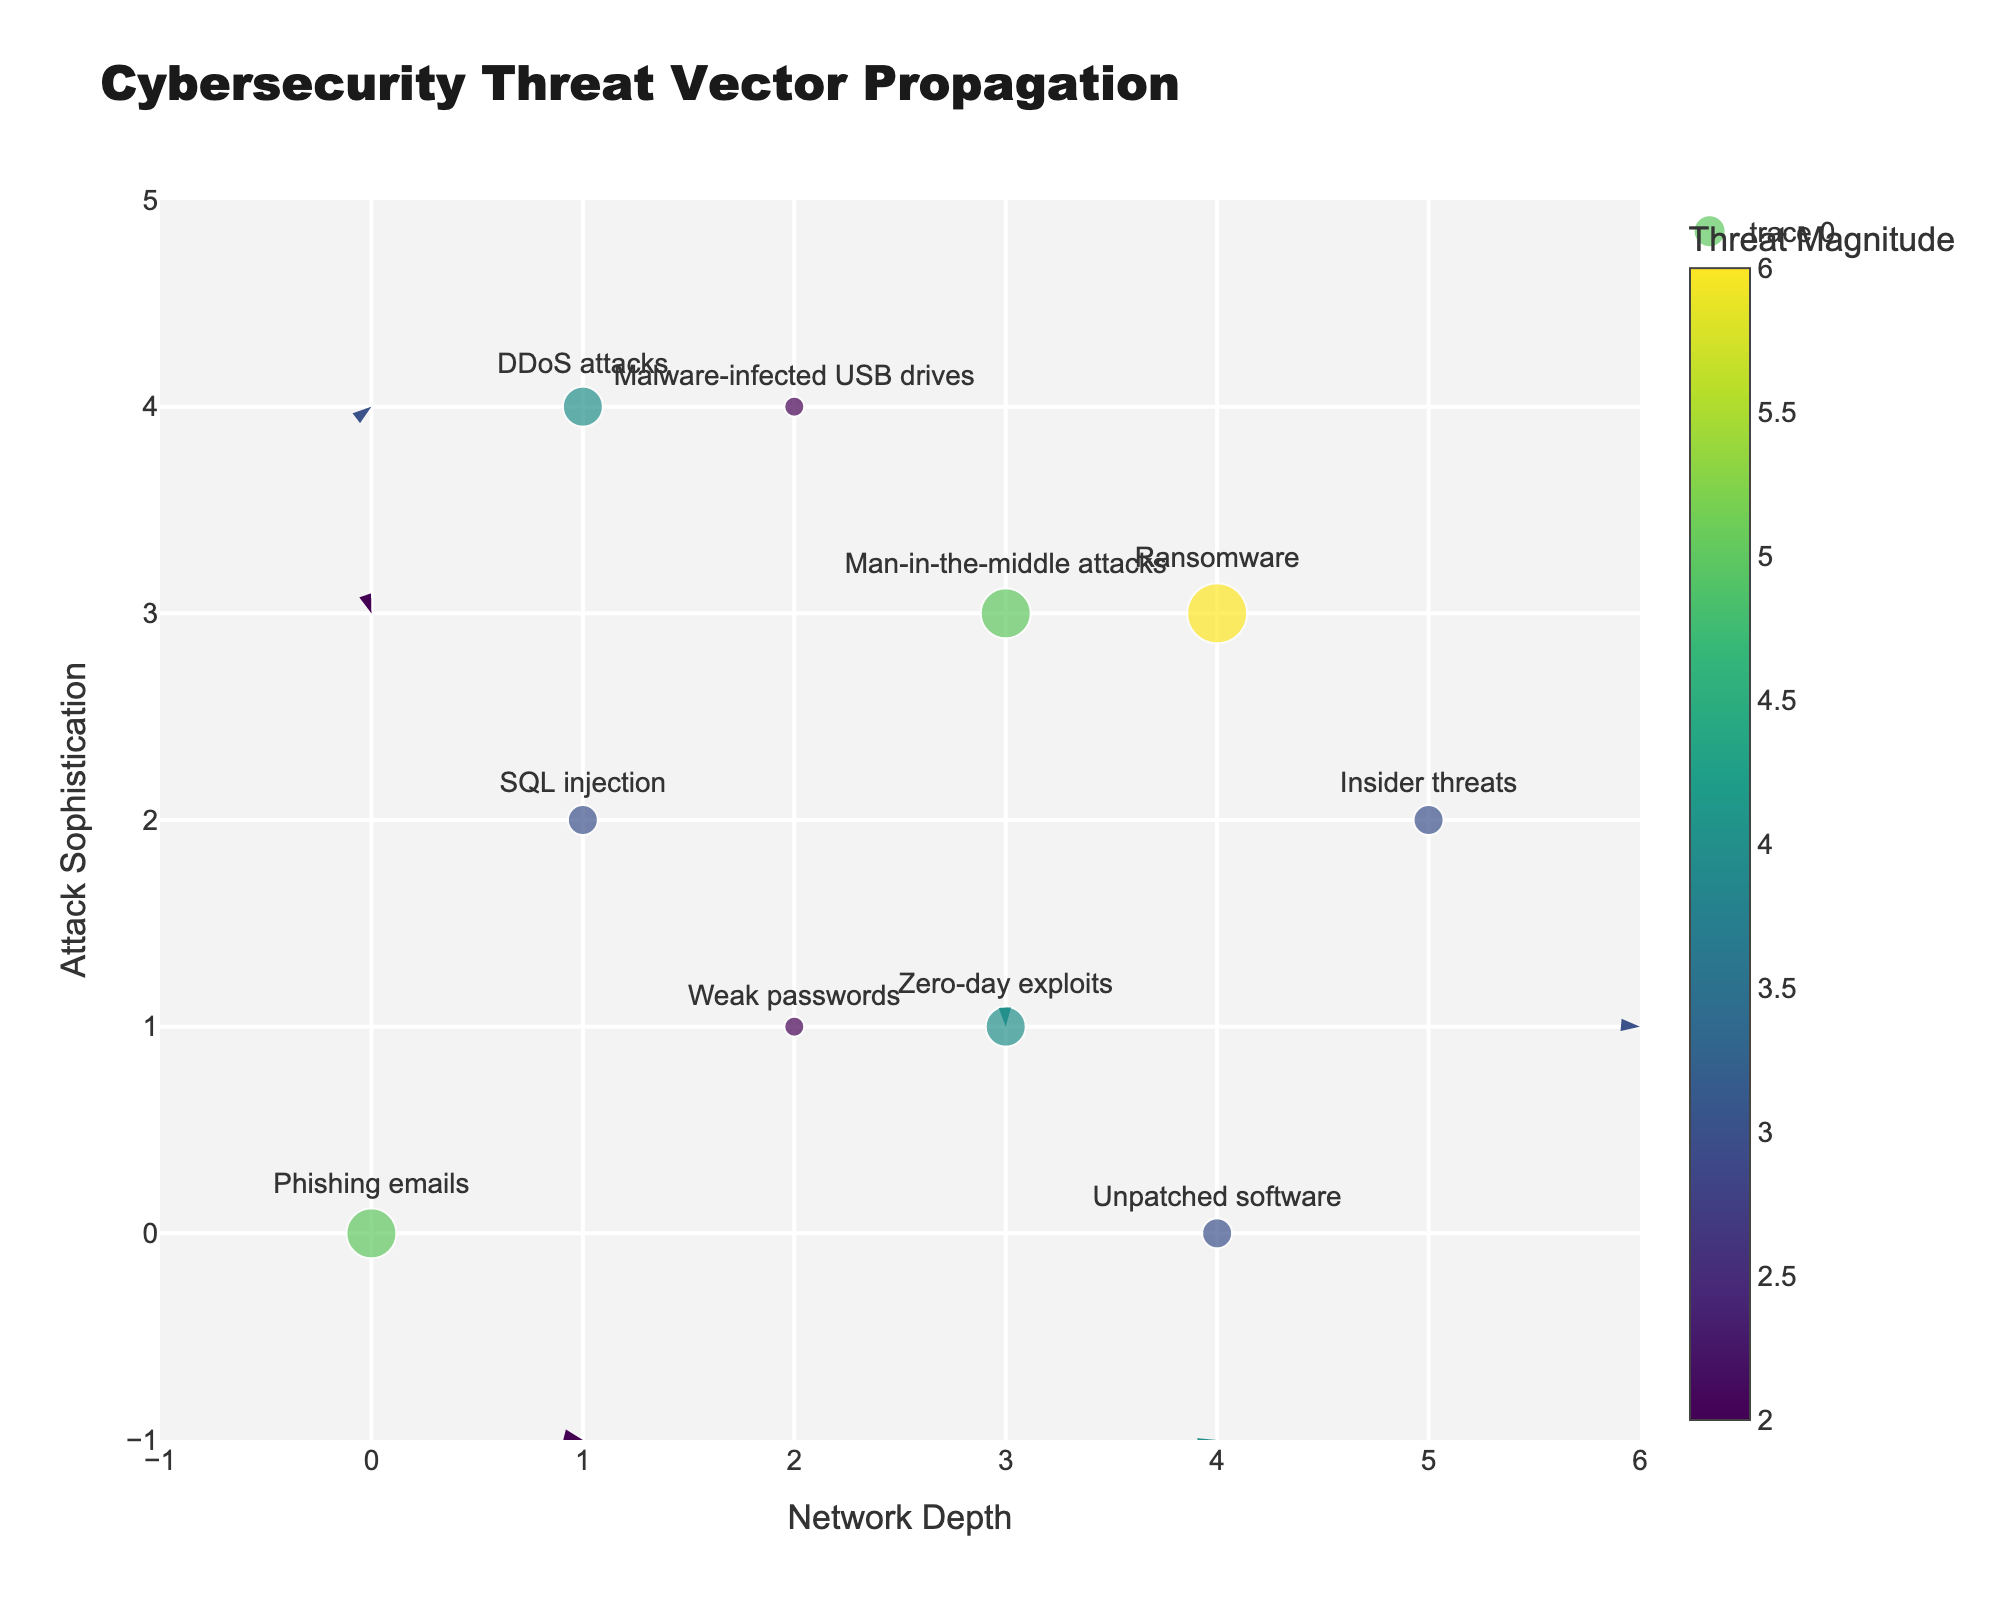what is the title of the plot? The title is usually the largest text at the top center of the figure. In this case, it reads "Cybersecurity Threat Vector Propagation" as specified in the code.
Answer: Cybersecurity Threat Vector Propagation what does the colorbar indicate? The colorbar is color-graded and titled "Threat Magnitude," which means it indicates the magnitude of each cybersecurity threat vector.
Answer: Threat Magnitude how many total threat vectors are represented in the plot? By counting the number of unique threat vectors indicated by the texts near the markers, we find there are 10 as listed in the data.
Answer: 10 which threat vector has the highest magnitude? Looking at the figure, the marker with the highest threat magnitude based on size and color is "Ransomware" with a magnitude of 6.
Answer: Ransomware what is the color of the marker indicating "Weak passwords"? By identifying the color corresponding to the magnitude value of 2 in the color scale (Viridis) on the colorbar, it shows a dark color.
Answer: Dark color where is the marker representing "DDoS attacks" located? The position of "DDoS attacks" can be found by locating the text for "DDoS attacks" next to its marker. It is at coordinates (1, 4).
Answer: (1, 4) how does the vector direction for "Insider threats" compare to "Zero-day exploits"? Comparing the directions, "Insider threats" points roughly upwards and to the right (positive direction), whereas "Zero-day exploits" points downwards and to the left (negative direction).
Answer: Opposite directions are there any threat vectors with a resultant motion purely horizontal or vertical? By analyzing each vector's u and v components: a purely horizontal vector has v=0, and a purely vertical vector has u=0. None of the vectors satisfy this.
Answer: None what is the endpoint of the vector originating at (4,3)? The vector originating at (4,3) represents "Ransomware" with (u,v) of (3,1). Therefore, the endpoint is (4+3, 3+1) = (7, 4).
Answer: (7, 4) which threat vector has the smallest magnitude and what is its direction? Finding the smallest magnitude in the dataset (2), "Weak passwords" fit this criterion. The vector direction is (-1, -2), pointing downwards to the left.
Answer: Weak passwords, downwards left 